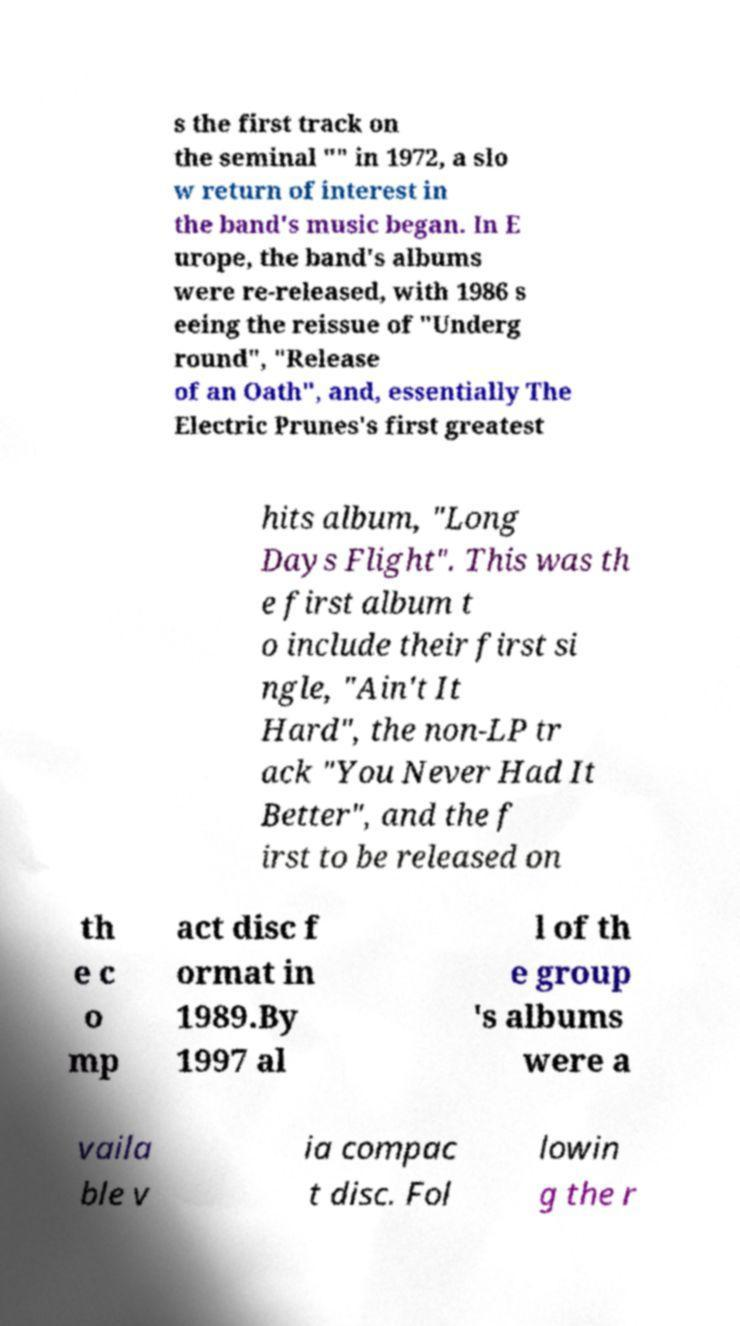For documentation purposes, I need the text within this image transcribed. Could you provide that? s the first track on the seminal "" in 1972, a slo w return of interest in the band's music began. In E urope, the band's albums were re-released, with 1986 s eeing the reissue of "Underg round", "Release of an Oath", and, essentially The Electric Prunes's first greatest hits album, "Long Days Flight". This was th e first album t o include their first si ngle, "Ain't It Hard", the non-LP tr ack "You Never Had It Better", and the f irst to be released on th e c o mp act disc f ormat in 1989.By 1997 al l of th e group 's albums were a vaila ble v ia compac t disc. Fol lowin g the r 